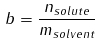Convert formula to latex. <formula><loc_0><loc_0><loc_500><loc_500>b = \frac { n _ { s o l u t e } } { m _ { s o l v e n t } }</formula> 